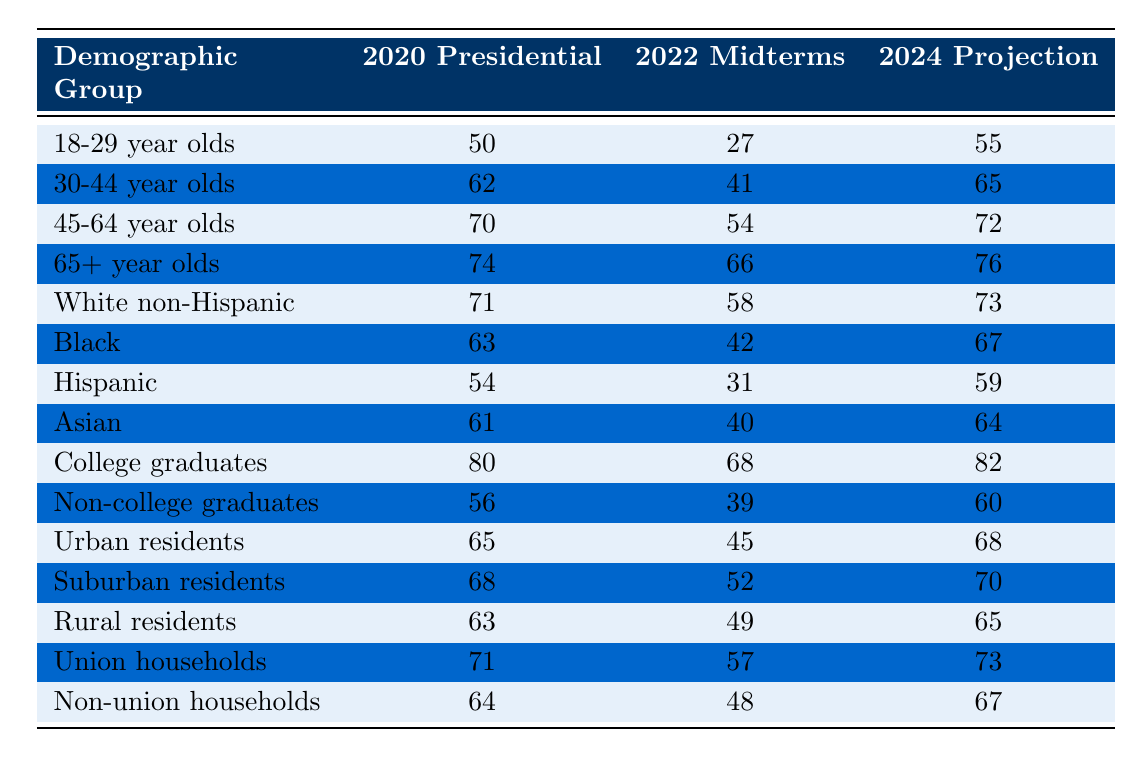What was the voter turnout rate for 18-29 year olds in the 2020 Presidential election? From the table, the specific turnout rate for the demographic group "18-29 year olds" in the "2020 Presidential" column is 50%.
Answer: 50 What was the voter turnout rate for Black voters in the 2022 Midterms? Referring to the table, the turnout rate for "Black" voters in the "2022 Midterms" column is 42%.
Answer: 42 How much did the voter turnout for 30-44 year olds increase from the 2022 Midterms to the 2024 Projection? The turnout for "30-44 year olds" in the "2022 Midterms" is 41% and is projected to be 65% in 2024. The increase is calculated as 65 - 41 = 24%.
Answer: 24 What is the turnout rate for Non-college graduates in the 2020 Presidential election compared to College graduates? The turnout for "Non-college graduates" is 56% and for "College graduates" is 80%. Non-college graduates have a lower turnout by 80 - 56 = 24%.
Answer: 24 Is the voter turnout for Rural residents in the 2022 Midterms higher than that of Hispanic voters? According to the table, "Rural residents" had a turnout of 49% in the 2022 Midterms, while "Hispanic" voters had a turnout rate of 31%. Since 49% is greater than 31%, the statement is true.
Answer: Yes Which demographic group had the highest voter turnout rate in the 2020 Presidential election, and what was that rate? Looking at the table, "College graduates" had the highest turnout rate of 80% in the "2020 Presidential" election.
Answer: College graduates, 80 What is the average voter turnout rate for the age group of 45-64 year olds across the three elections listed? The turnout rates for "45-64 year olds" are 70% in 2020, 54% in 2022, and a projected 72% in 2024. The average is calculated as (70 + 54 + 72) / 3 = 65.33%.
Answer: 65.33 For which demographic group is a turnout of 76% projected in 2024? According to the table, the group projected to have a turnout of 76% in 2024 is "65+ year olds".
Answer: 65+ year olds Which demographic group showed the least turnout in the 2022 Midterms? The "Hispanic" demographic had the lowest turnout rate of 31% in the "2022 Midterms" according to the table.
Answer: Hispanic What will be the difference in voter turnout rates for Urban residents from the 2020 Presidential to the 2024 Projection? The turnout for "Urban residents" is 65% in 2020 and projected to be 68% in 2024. The difference is 68 - 65 = 3%.
Answer: 3 